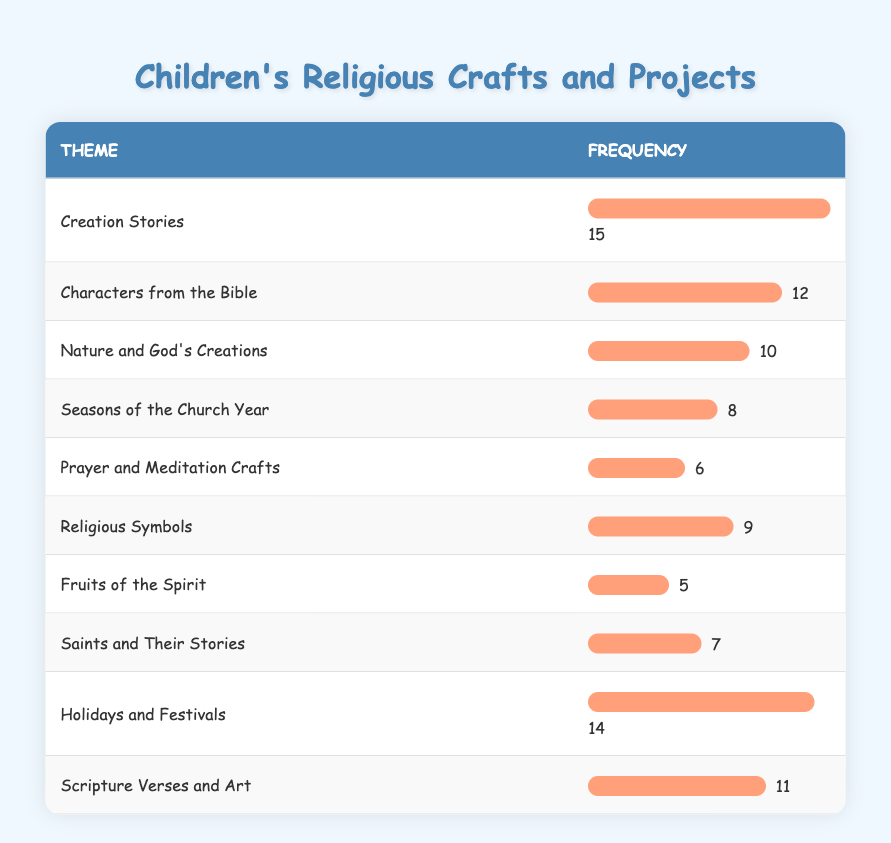What theme has the highest frequency in children's religious crafts? The table shows that the theme with the highest frequency is "Creation Stories," which has a frequency of 15.
Answer: Creation Stories How many themes have a frequency of 10 or more? By reviewing the table, I see that the themes with a frequency of 10 or more are "Creation Stories" (15), "Holidays and Festivals" (14), "Characters from the Bible" (12), "Scripture Verses and Art" (11), and "Nature and God's Creations" (10). This totals to 5 themes.
Answer: 5 Is "Prayer and Meditation Crafts" one of the least frequent themes? The frequency of "Prayer and Meditation Crafts" is 6. Looking at the table, this is indeed one of the least frequent themes, as there are three themes with lower frequencies (Fruits of the Spirit with 5, Saints and Their Stories with 7, and Prayer and Meditation Crafts itself).
Answer: Yes What is the difference in frequency between "Holidays and Festivals" and "Seasons of the Church Year"? "Holidays and Festivals" has a frequency of 14 and "Seasons of the Church Year" has a frequency of 8. The difference is 14 - 8 = 6.
Answer: 6 Which theme has a frequency closest to the average frequency of all themes? To find the average frequency, I total all the frequencies: 15 + 12 + 10 + 8 + 6 + 9 + 5 + 7 + 14 + 11 =  87. There are 10 themes, so the average is 87 / 10 = 8.7. The closest frequencies to this average are for "Seasons of the Church Year" (8) and "Prayer and Meditation Crafts" (6), but "Seasons of the Church Year" is the nearest.
Answer: Seasons of the Church Year 